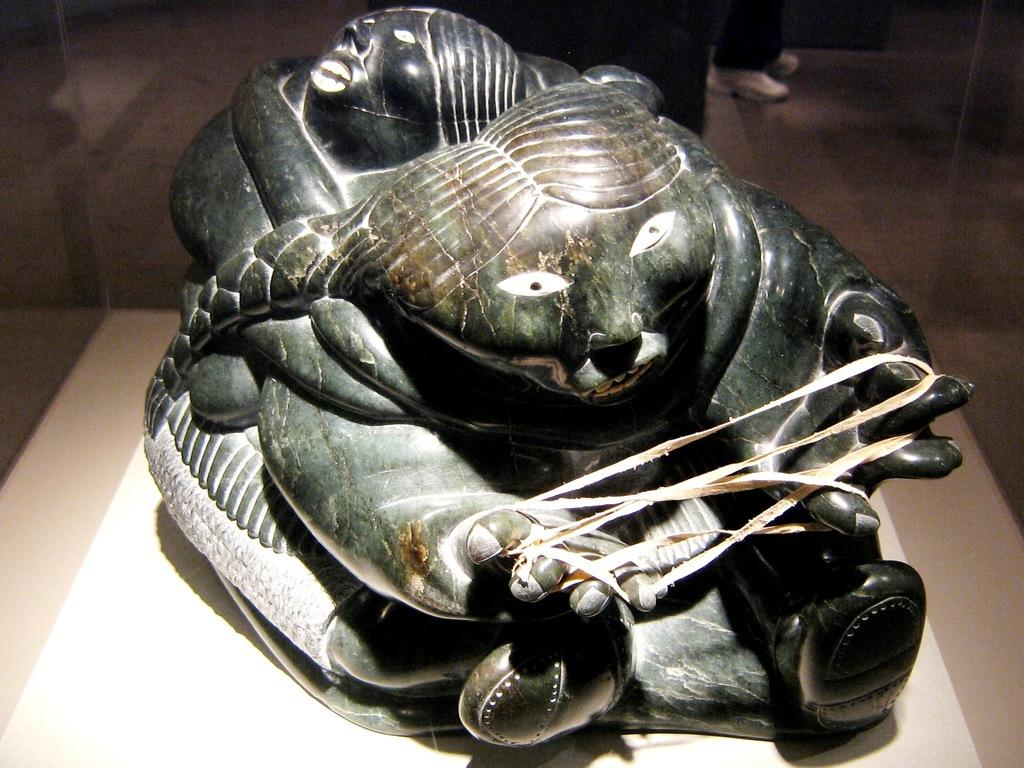What is the main subject of the image? There is a marble statue in the image. What is unique about the statue? The statue has thread tied to its fingers. On what surface is the statue placed? The statue is placed on a surface. What can be seen on the backside of the statue? There are legs of a person visible on the backside of the statue. How are the legs of the person positioned? The legs of the person are on the floor. What type of tomatoes can be seen growing on the statue's throat in the image? There are no tomatoes or any plant life visible on the statue's throat in the image. How many cups are being held by the statue in the image? There are no cups present in the image; the statue has thread tied to its fingers. 